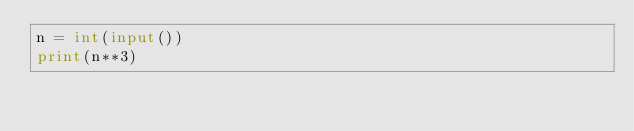Convert code to text. <code><loc_0><loc_0><loc_500><loc_500><_Python_>n = int(input())
print(n**3)</code> 